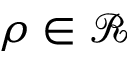Convert formula to latex. <formula><loc_0><loc_0><loc_500><loc_500>\rho \in \mathcal { R }</formula> 